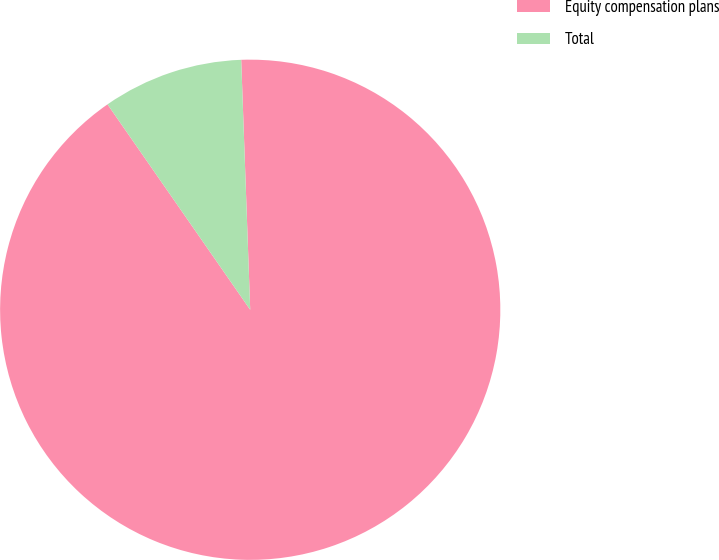<chart> <loc_0><loc_0><loc_500><loc_500><pie_chart><fcel>Equity compensation plans<fcel>Total<nl><fcel>90.91%<fcel>9.09%<nl></chart> 